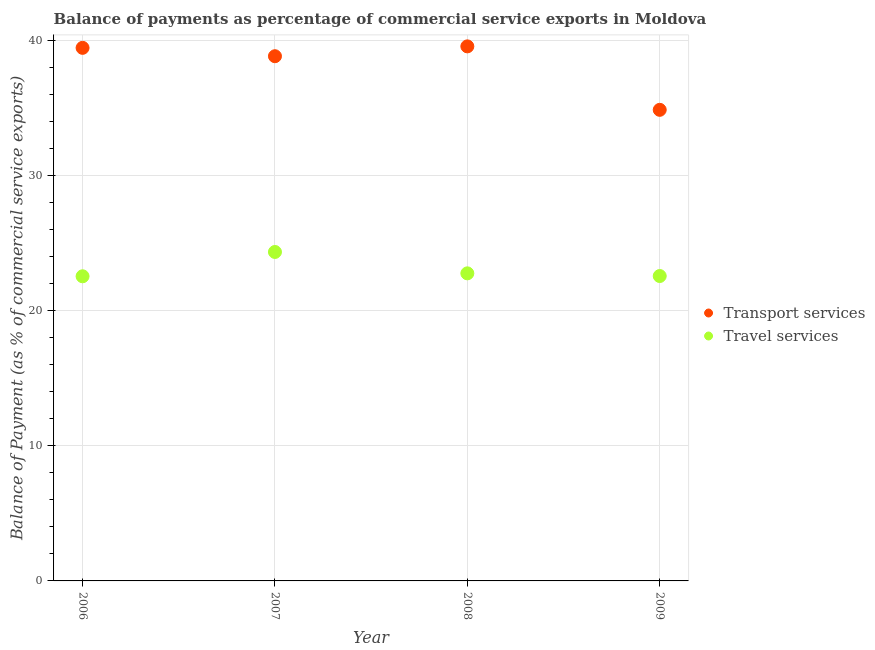How many different coloured dotlines are there?
Your response must be concise. 2. Is the number of dotlines equal to the number of legend labels?
Your answer should be very brief. Yes. What is the balance of payments of transport services in 2008?
Ensure brevity in your answer.  39.59. Across all years, what is the maximum balance of payments of travel services?
Keep it short and to the point. 24.36. Across all years, what is the minimum balance of payments of transport services?
Make the answer very short. 34.89. In which year was the balance of payments of travel services maximum?
Offer a terse response. 2007. In which year was the balance of payments of travel services minimum?
Your answer should be compact. 2006. What is the total balance of payments of travel services in the graph?
Your response must be concise. 92.29. What is the difference between the balance of payments of transport services in 2006 and that in 2009?
Ensure brevity in your answer.  4.59. What is the difference between the balance of payments of transport services in 2006 and the balance of payments of travel services in 2009?
Offer a terse response. 16.9. What is the average balance of payments of travel services per year?
Offer a terse response. 23.07. In the year 2009, what is the difference between the balance of payments of travel services and balance of payments of transport services?
Offer a terse response. -12.31. In how many years, is the balance of payments of travel services greater than 12 %?
Give a very brief answer. 4. What is the ratio of the balance of payments of travel services in 2007 to that in 2008?
Give a very brief answer. 1.07. Is the balance of payments of transport services in 2006 less than that in 2009?
Ensure brevity in your answer.  No. What is the difference between the highest and the second highest balance of payments of travel services?
Your answer should be compact. 1.58. What is the difference between the highest and the lowest balance of payments of travel services?
Your response must be concise. 1.8. Does the balance of payments of travel services monotonically increase over the years?
Provide a succinct answer. No. Is the balance of payments of travel services strictly greater than the balance of payments of transport services over the years?
Your answer should be very brief. No. How many dotlines are there?
Keep it short and to the point. 2. What is the difference between two consecutive major ticks on the Y-axis?
Keep it short and to the point. 10. Are the values on the major ticks of Y-axis written in scientific E-notation?
Ensure brevity in your answer.  No. Does the graph contain grids?
Provide a short and direct response. Yes. What is the title of the graph?
Give a very brief answer. Balance of payments as percentage of commercial service exports in Moldova. Does "Non-pregnant women" appear as one of the legend labels in the graph?
Your answer should be compact. No. What is the label or title of the Y-axis?
Provide a short and direct response. Balance of Payment (as % of commercial service exports). What is the Balance of Payment (as % of commercial service exports) of Transport services in 2006?
Keep it short and to the point. 39.48. What is the Balance of Payment (as % of commercial service exports) of Travel services in 2006?
Provide a short and direct response. 22.56. What is the Balance of Payment (as % of commercial service exports) of Transport services in 2007?
Offer a very short reply. 38.86. What is the Balance of Payment (as % of commercial service exports) in Travel services in 2007?
Keep it short and to the point. 24.36. What is the Balance of Payment (as % of commercial service exports) in Transport services in 2008?
Offer a very short reply. 39.59. What is the Balance of Payment (as % of commercial service exports) of Travel services in 2008?
Offer a terse response. 22.78. What is the Balance of Payment (as % of commercial service exports) of Transport services in 2009?
Offer a terse response. 34.89. What is the Balance of Payment (as % of commercial service exports) in Travel services in 2009?
Provide a succinct answer. 22.58. Across all years, what is the maximum Balance of Payment (as % of commercial service exports) of Transport services?
Offer a very short reply. 39.59. Across all years, what is the maximum Balance of Payment (as % of commercial service exports) in Travel services?
Your answer should be very brief. 24.36. Across all years, what is the minimum Balance of Payment (as % of commercial service exports) in Transport services?
Your response must be concise. 34.89. Across all years, what is the minimum Balance of Payment (as % of commercial service exports) in Travel services?
Offer a terse response. 22.56. What is the total Balance of Payment (as % of commercial service exports) in Transport services in the graph?
Provide a succinct answer. 152.82. What is the total Balance of Payment (as % of commercial service exports) in Travel services in the graph?
Ensure brevity in your answer.  92.29. What is the difference between the Balance of Payment (as % of commercial service exports) in Transport services in 2006 and that in 2007?
Provide a short and direct response. 0.62. What is the difference between the Balance of Payment (as % of commercial service exports) of Travel services in 2006 and that in 2007?
Provide a succinct answer. -1.8. What is the difference between the Balance of Payment (as % of commercial service exports) in Transport services in 2006 and that in 2008?
Your response must be concise. -0.11. What is the difference between the Balance of Payment (as % of commercial service exports) of Travel services in 2006 and that in 2008?
Give a very brief answer. -0.22. What is the difference between the Balance of Payment (as % of commercial service exports) in Transport services in 2006 and that in 2009?
Offer a terse response. 4.59. What is the difference between the Balance of Payment (as % of commercial service exports) in Travel services in 2006 and that in 2009?
Make the answer very short. -0.02. What is the difference between the Balance of Payment (as % of commercial service exports) of Transport services in 2007 and that in 2008?
Offer a very short reply. -0.73. What is the difference between the Balance of Payment (as % of commercial service exports) of Travel services in 2007 and that in 2008?
Offer a very short reply. 1.58. What is the difference between the Balance of Payment (as % of commercial service exports) in Transport services in 2007 and that in 2009?
Offer a very short reply. 3.97. What is the difference between the Balance of Payment (as % of commercial service exports) of Travel services in 2007 and that in 2009?
Give a very brief answer. 1.78. What is the difference between the Balance of Payment (as % of commercial service exports) in Transport services in 2008 and that in 2009?
Make the answer very short. 4.7. What is the difference between the Balance of Payment (as % of commercial service exports) in Travel services in 2008 and that in 2009?
Ensure brevity in your answer.  0.2. What is the difference between the Balance of Payment (as % of commercial service exports) of Transport services in 2006 and the Balance of Payment (as % of commercial service exports) of Travel services in 2007?
Keep it short and to the point. 15.12. What is the difference between the Balance of Payment (as % of commercial service exports) in Transport services in 2006 and the Balance of Payment (as % of commercial service exports) in Travel services in 2008?
Offer a very short reply. 16.7. What is the difference between the Balance of Payment (as % of commercial service exports) of Transport services in 2006 and the Balance of Payment (as % of commercial service exports) of Travel services in 2009?
Offer a terse response. 16.9. What is the difference between the Balance of Payment (as % of commercial service exports) of Transport services in 2007 and the Balance of Payment (as % of commercial service exports) of Travel services in 2008?
Provide a short and direct response. 16.08. What is the difference between the Balance of Payment (as % of commercial service exports) of Transport services in 2007 and the Balance of Payment (as % of commercial service exports) of Travel services in 2009?
Make the answer very short. 16.28. What is the difference between the Balance of Payment (as % of commercial service exports) in Transport services in 2008 and the Balance of Payment (as % of commercial service exports) in Travel services in 2009?
Your answer should be compact. 17.01. What is the average Balance of Payment (as % of commercial service exports) of Transport services per year?
Provide a short and direct response. 38.21. What is the average Balance of Payment (as % of commercial service exports) in Travel services per year?
Give a very brief answer. 23.07. In the year 2006, what is the difference between the Balance of Payment (as % of commercial service exports) in Transport services and Balance of Payment (as % of commercial service exports) in Travel services?
Offer a very short reply. 16.92. In the year 2007, what is the difference between the Balance of Payment (as % of commercial service exports) in Transport services and Balance of Payment (as % of commercial service exports) in Travel services?
Make the answer very short. 14.5. In the year 2008, what is the difference between the Balance of Payment (as % of commercial service exports) in Transport services and Balance of Payment (as % of commercial service exports) in Travel services?
Keep it short and to the point. 16.81. In the year 2009, what is the difference between the Balance of Payment (as % of commercial service exports) in Transport services and Balance of Payment (as % of commercial service exports) in Travel services?
Keep it short and to the point. 12.31. What is the ratio of the Balance of Payment (as % of commercial service exports) in Transport services in 2006 to that in 2007?
Your response must be concise. 1.02. What is the ratio of the Balance of Payment (as % of commercial service exports) of Travel services in 2006 to that in 2007?
Provide a succinct answer. 0.93. What is the ratio of the Balance of Payment (as % of commercial service exports) in Travel services in 2006 to that in 2008?
Give a very brief answer. 0.99. What is the ratio of the Balance of Payment (as % of commercial service exports) in Transport services in 2006 to that in 2009?
Keep it short and to the point. 1.13. What is the ratio of the Balance of Payment (as % of commercial service exports) of Transport services in 2007 to that in 2008?
Offer a very short reply. 0.98. What is the ratio of the Balance of Payment (as % of commercial service exports) of Travel services in 2007 to that in 2008?
Your answer should be very brief. 1.07. What is the ratio of the Balance of Payment (as % of commercial service exports) of Transport services in 2007 to that in 2009?
Provide a short and direct response. 1.11. What is the ratio of the Balance of Payment (as % of commercial service exports) of Travel services in 2007 to that in 2009?
Keep it short and to the point. 1.08. What is the ratio of the Balance of Payment (as % of commercial service exports) in Transport services in 2008 to that in 2009?
Provide a short and direct response. 1.13. What is the ratio of the Balance of Payment (as % of commercial service exports) in Travel services in 2008 to that in 2009?
Keep it short and to the point. 1.01. What is the difference between the highest and the second highest Balance of Payment (as % of commercial service exports) in Transport services?
Offer a very short reply. 0.11. What is the difference between the highest and the second highest Balance of Payment (as % of commercial service exports) in Travel services?
Your answer should be compact. 1.58. What is the difference between the highest and the lowest Balance of Payment (as % of commercial service exports) in Transport services?
Give a very brief answer. 4.7. What is the difference between the highest and the lowest Balance of Payment (as % of commercial service exports) in Travel services?
Provide a short and direct response. 1.8. 